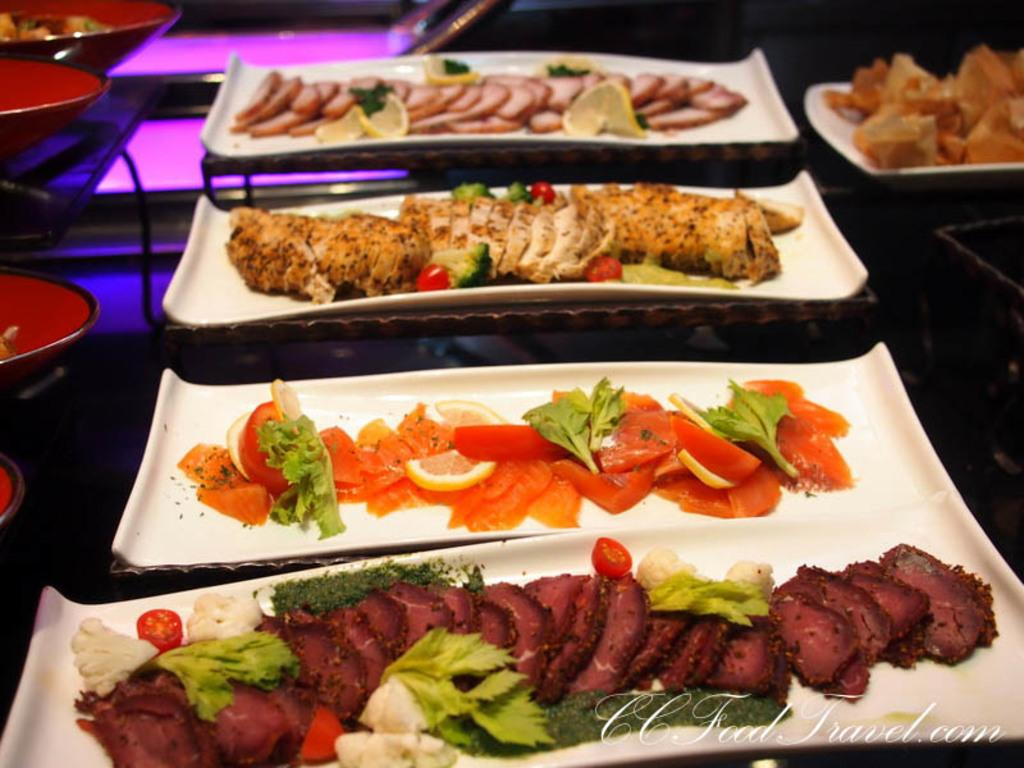What objects are in the foreground of the image? There are trays in the foreground of the image. What is on the trays? The trays contain food items. Where are the utensils located in the image? The utensils are on the left side of the image. Can you see a kitten playing with a star in the image? There is no kitten or star present in the image. 